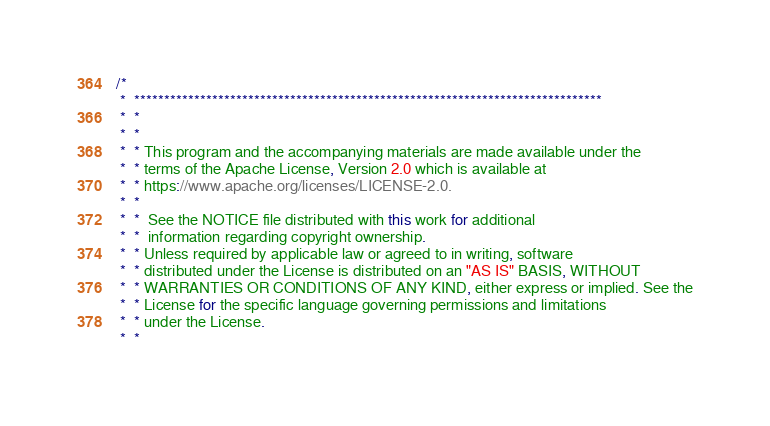Convert code to text. <code><loc_0><loc_0><loc_500><loc_500><_Java_>/*
 *  ******************************************************************************
 *  *
 *  *
 *  * This program and the accompanying materials are made available under the
 *  * terms of the Apache License, Version 2.0 which is available at
 *  * https://www.apache.org/licenses/LICENSE-2.0.
 *  *
 *  *  See the NOTICE file distributed with this work for additional
 *  *  information regarding copyright ownership.
 *  * Unless required by applicable law or agreed to in writing, software
 *  * distributed under the License is distributed on an "AS IS" BASIS, WITHOUT
 *  * WARRANTIES OR CONDITIONS OF ANY KIND, either express or implied. See the
 *  * License for the specific language governing permissions and limitations
 *  * under the License.
 *  *</code> 